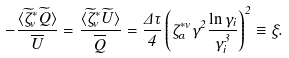<formula> <loc_0><loc_0><loc_500><loc_500>- \frac { \langle \widetilde { \zeta } _ { v } ^ { * } \widetilde { Q } \rangle } { \overline { U } } = \frac { \langle \widetilde { \zeta } _ { v } ^ { * } \widetilde { U } \rangle } { \overline { Q } } = \frac { \Delta \tau } { 4 } \left ( \zeta _ { \alpha } ^ { * v } \gamma ^ { 2 } \frac { \ln \gamma _ { i } } { \gamma _ { i } ^ { 3 } } \right ) ^ { 2 } \equiv \xi .</formula> 